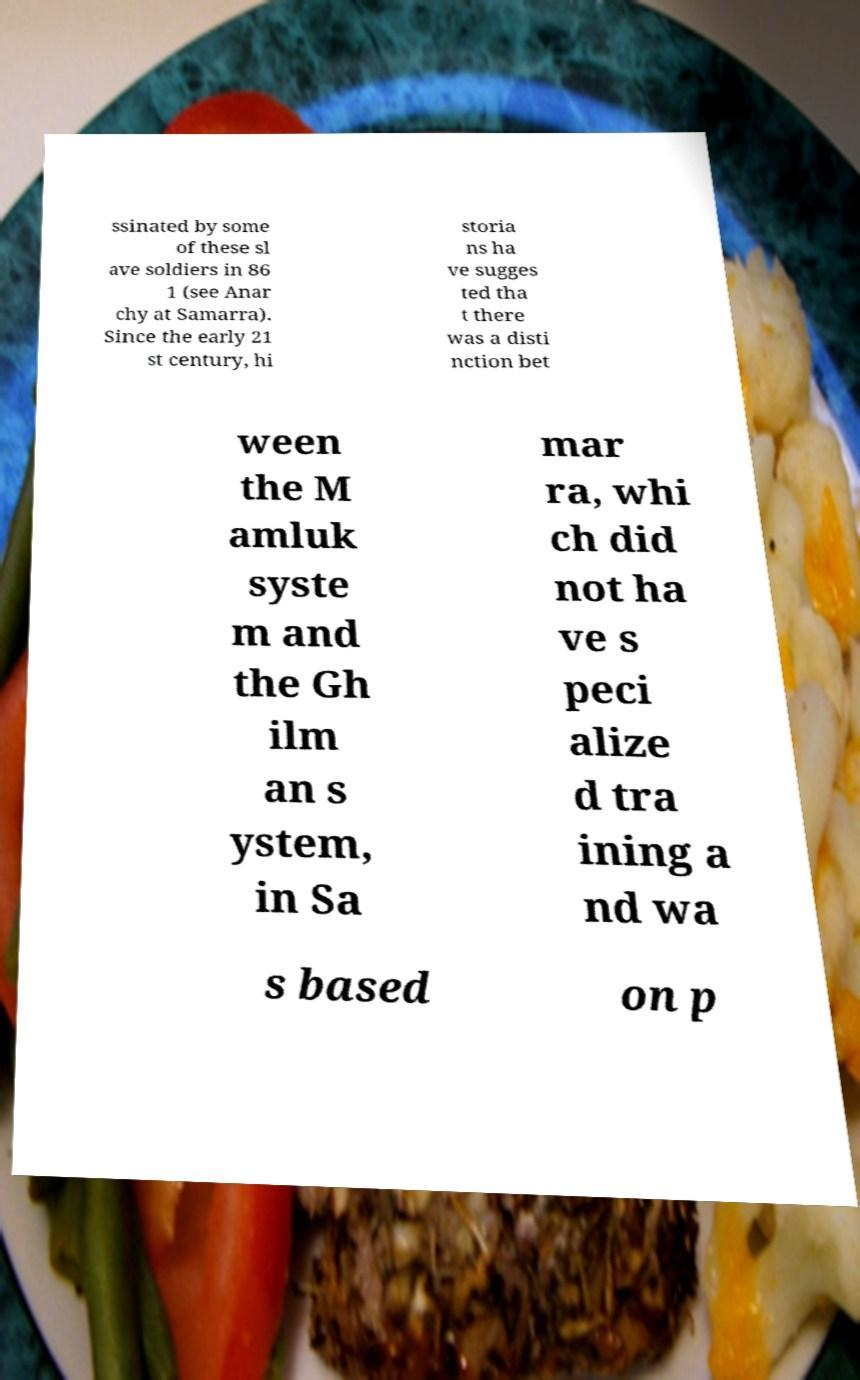Could you assist in decoding the text presented in this image and type it out clearly? ssinated by some of these sl ave soldiers in 86 1 (see Anar chy at Samarra). Since the early 21 st century, hi storia ns ha ve sugges ted tha t there was a disti nction bet ween the M amluk syste m and the Gh ilm an s ystem, in Sa mar ra, whi ch did not ha ve s peci alize d tra ining a nd wa s based on p 